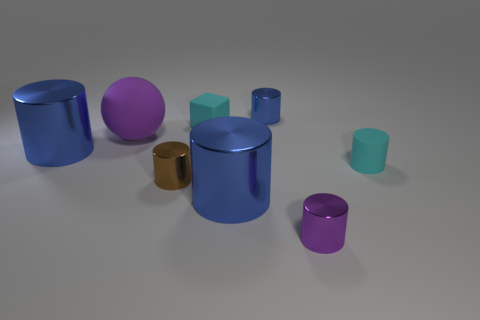There is a cyan cylinder that is the same size as the cube; what is it made of?
Ensure brevity in your answer.  Rubber. Is there a matte sphere that has the same size as the rubber block?
Provide a short and direct response. No. Is the shape of the brown shiny object the same as the large purple rubber object?
Ensure brevity in your answer.  No. There is a small cyan object that is in front of the cyan thing that is on the left side of the tiny purple object; is there a metal cylinder in front of it?
Your answer should be very brief. Yes. How many other things are there of the same color as the tiny matte cylinder?
Keep it short and to the point. 1. There is a blue cylinder behind the cyan cube; is its size the same as the brown metal cylinder that is on the right side of the ball?
Offer a terse response. Yes. Are there an equal number of small cyan matte cubes that are in front of the small cyan rubber cylinder and blue cylinders behind the tiny rubber block?
Make the answer very short. No. Is there any other thing that is made of the same material as the small block?
Your answer should be compact. Yes. There is a purple metallic thing; does it have the same size as the thing left of the large purple ball?
Give a very brief answer. No. What material is the purple thing that is left of the tiny cyan matte object left of the small blue shiny cylinder made of?
Offer a very short reply. Rubber. 